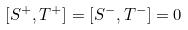<formula> <loc_0><loc_0><loc_500><loc_500>[ S ^ { + } , T ^ { + } ] = [ S ^ { - } , T ^ { - } ] = 0</formula> 